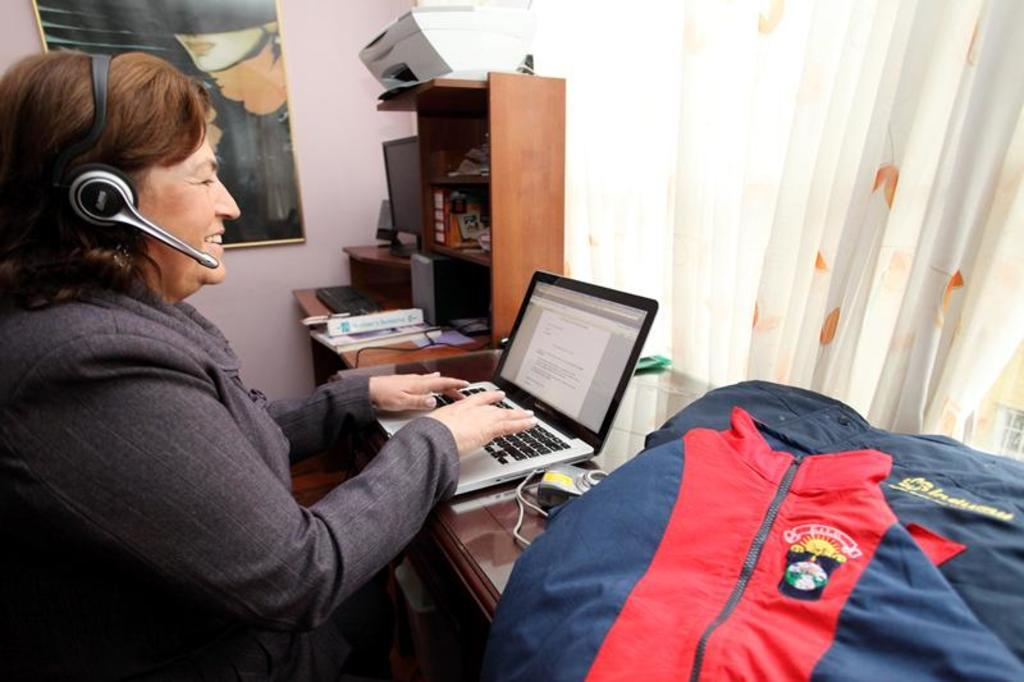Who is the main subject in the image? There is a woman in the image. Where is the woman sitting in the image? The woman is sitting on the left side. What is the woman doing in the image? The woman is working on a laptop. What is the woman wearing in the image? The woman is wearing a coat and a headset. What can be seen on the right side of the image? There is a curtain on the right side of the image. What type of joke is the woman telling to the fan in the image? There is no fan or joke present in the image. How does the woman use the hole in the curtain to communicate with others in the image? There is no hole in the curtain, and the woman is not communicating with others in the image. 